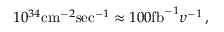<formula> <loc_0><loc_0><loc_500><loc_500>1 0 ^ { 3 4 } c m ^ { - 2 } s e c ^ { - 1 } \approx 1 0 0 f b ^ { - 1 } \upsilon ^ { - 1 } \, ,</formula> 